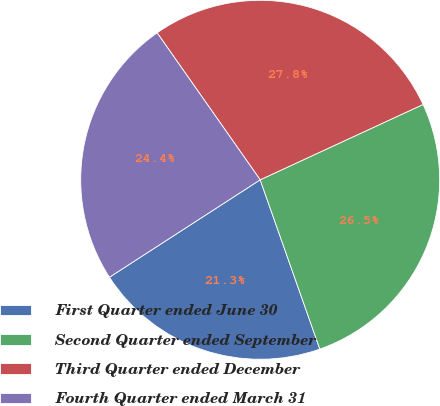<chart> <loc_0><loc_0><loc_500><loc_500><pie_chart><fcel>First Quarter ended June 30<fcel>Second Quarter ended September<fcel>Third Quarter ended December<fcel>Fourth Quarter ended March 31<nl><fcel>21.26%<fcel>26.5%<fcel>27.84%<fcel>24.4%<nl></chart> 